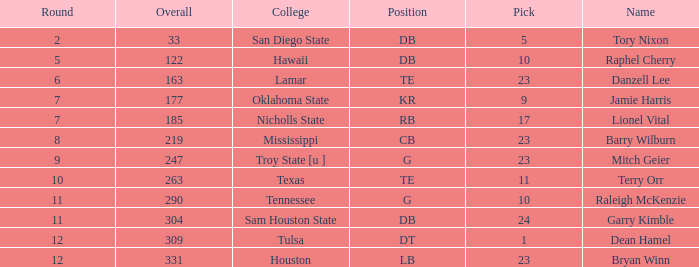How many Picks have a College of hawaii, and an Overall smaller than 122? 0.0. 